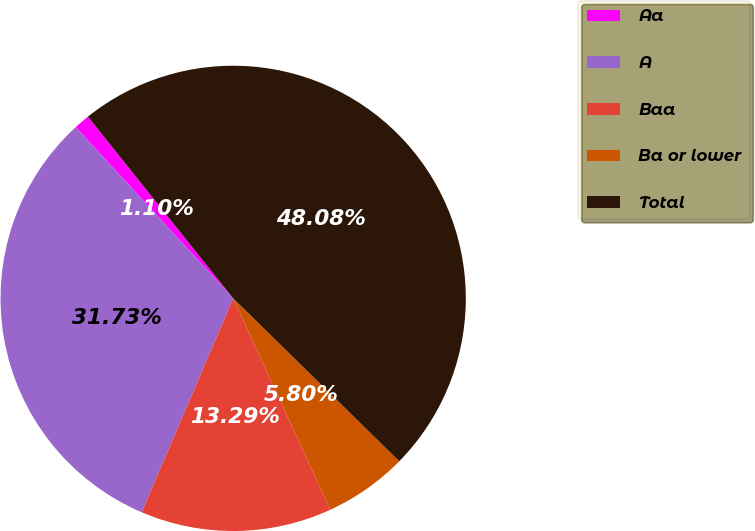Convert chart. <chart><loc_0><loc_0><loc_500><loc_500><pie_chart><fcel>Aa<fcel>A<fcel>Baa<fcel>Ba or lower<fcel>Total<nl><fcel>1.1%<fcel>31.73%<fcel>13.29%<fcel>5.8%<fcel>48.08%<nl></chart> 